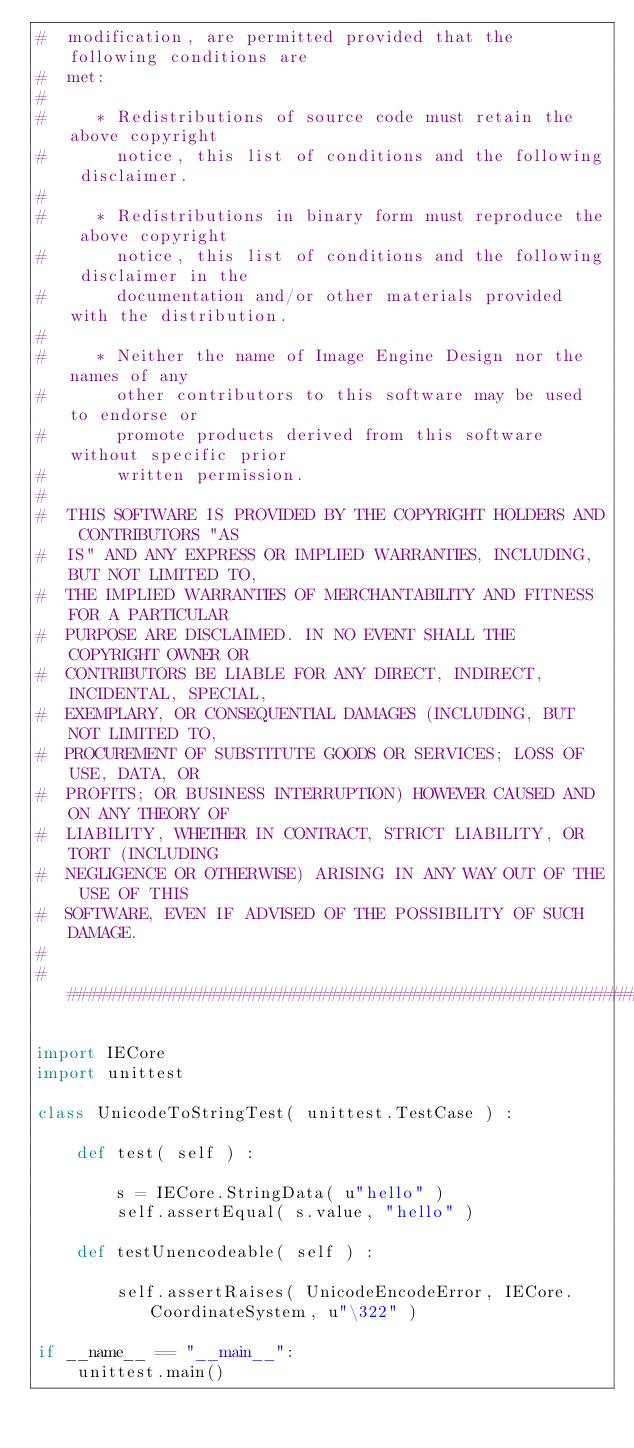Convert code to text. <code><loc_0><loc_0><loc_500><loc_500><_Python_>#  modification, are permitted provided that the following conditions are
#  met:
#
#     * Redistributions of source code must retain the above copyright
#       notice, this list of conditions and the following disclaimer.
#
#     * Redistributions in binary form must reproduce the above copyright
#       notice, this list of conditions and the following disclaimer in the
#       documentation and/or other materials provided with the distribution.
#
#     * Neither the name of Image Engine Design nor the names of any
#       other contributors to this software may be used to endorse or
#       promote products derived from this software without specific prior
#       written permission.
#
#  THIS SOFTWARE IS PROVIDED BY THE COPYRIGHT HOLDERS AND CONTRIBUTORS "AS
#  IS" AND ANY EXPRESS OR IMPLIED WARRANTIES, INCLUDING, BUT NOT LIMITED TO,
#  THE IMPLIED WARRANTIES OF MERCHANTABILITY AND FITNESS FOR A PARTICULAR
#  PURPOSE ARE DISCLAIMED. IN NO EVENT SHALL THE COPYRIGHT OWNER OR
#  CONTRIBUTORS BE LIABLE FOR ANY DIRECT, INDIRECT, INCIDENTAL, SPECIAL,
#  EXEMPLARY, OR CONSEQUENTIAL DAMAGES (INCLUDING, BUT NOT LIMITED TO,
#  PROCUREMENT OF SUBSTITUTE GOODS OR SERVICES; LOSS OF USE, DATA, OR
#  PROFITS; OR BUSINESS INTERRUPTION) HOWEVER CAUSED AND ON ANY THEORY OF
#  LIABILITY, WHETHER IN CONTRACT, STRICT LIABILITY, OR TORT (INCLUDING
#  NEGLIGENCE OR OTHERWISE) ARISING IN ANY WAY OUT OF THE USE OF THIS
#  SOFTWARE, EVEN IF ADVISED OF THE POSSIBILITY OF SUCH DAMAGE.
#
##########################################################################

import IECore
import unittest

class UnicodeToStringTest( unittest.TestCase ) :

	def test( self ) :

		s = IECore.StringData( u"hello" )
		self.assertEqual( s.value, "hello" )

	def testUnencodeable( self ) :
	
		self.assertRaises( UnicodeEncodeError, IECore.CoordinateSystem, u"\322" )
		
if __name__ == "__main__":
	unittest.main()

</code> 